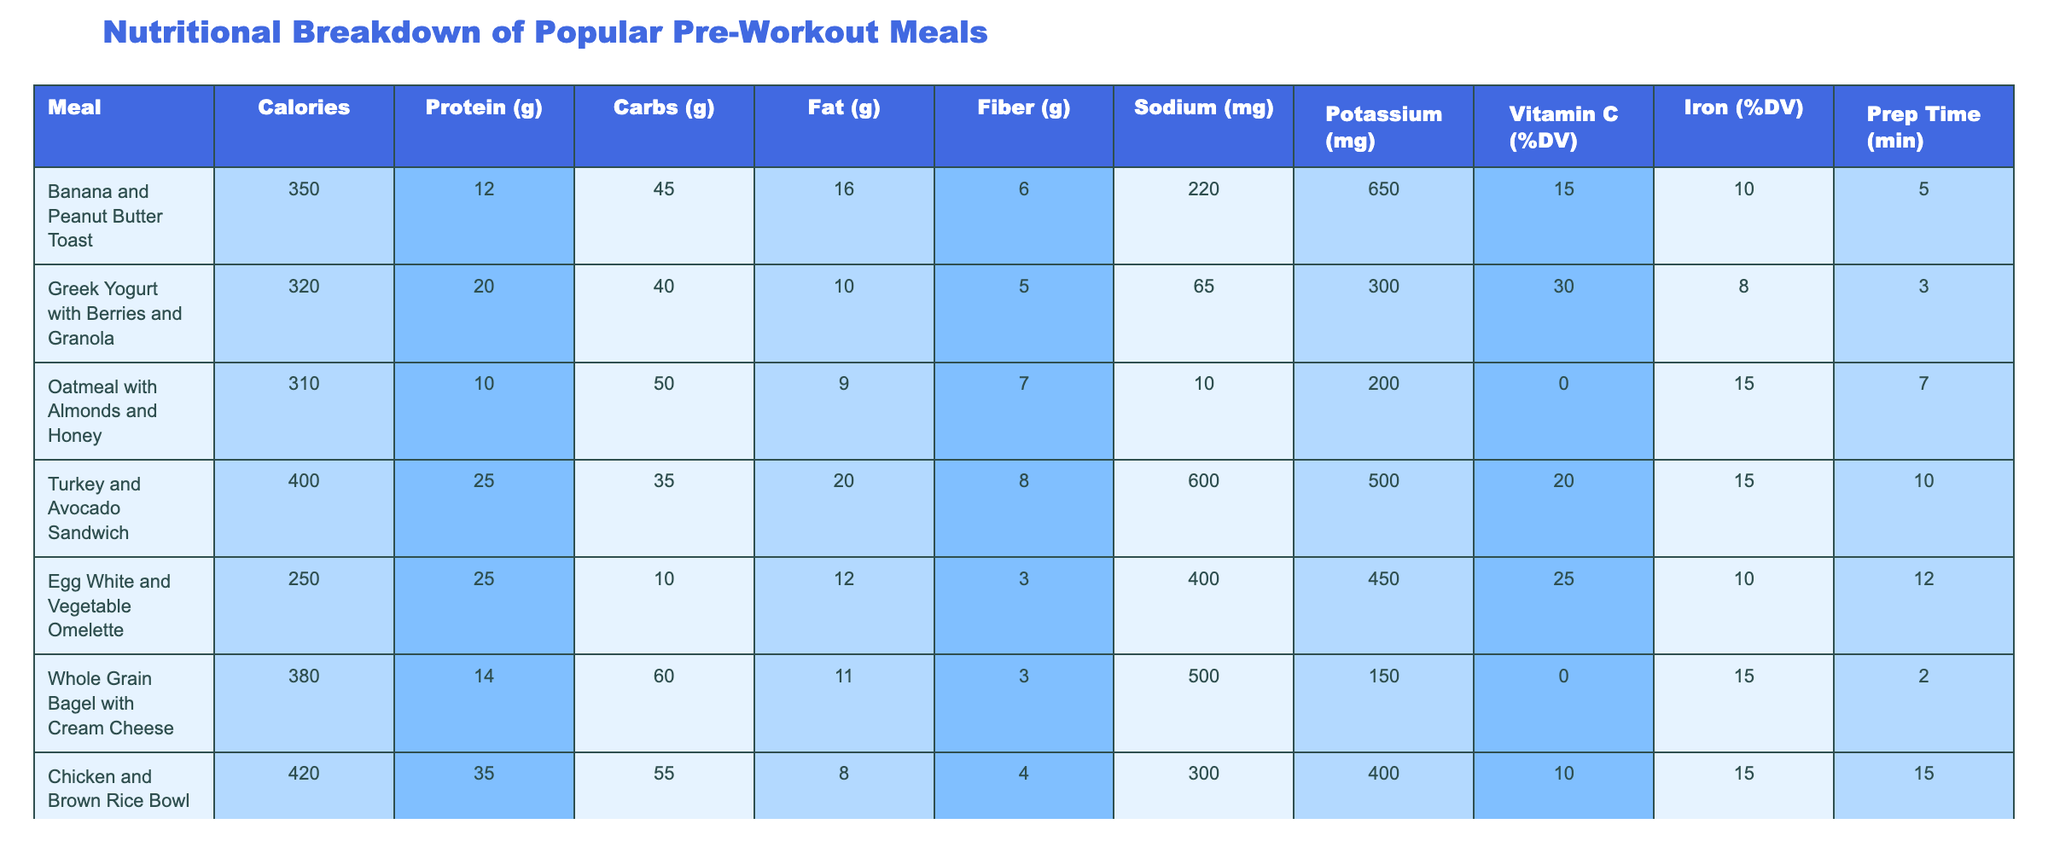What is the meal with the highest protein content? By scanning the protein content values in the table, we find that the "Chicken and Brown Rice Bowl" has the highest protein content at 35 grams.
Answer: Chicken and Brown Rice Bowl Which meal has the least calories? The meal with the least calories, as visible from the table, is the "Egg White and Vegetable Omelette" at 250 calories.
Answer: Egg White and Vegetable Omelette What is the total carbohydrate content of "Greek Yogurt with Berries and Granola" and "Oatmeal with Almonds and Honey"? The carbohydrate content for "Greek Yogurt with Berries and Granola" is 40 grams and for "Oatmeal with Almonds and Honey" is 50 grams. Adding these together gives us 40 + 50 = 90 grams of carbs.
Answer: 90 grams Does any meal provide more than 25% of the daily value for Vitamin C? We can check the Vitamin C percentage for all meals. The "Greek Yogurt with Berries and Granola" and "Egg White and Vegetable Omelette" both provide 30% and 25% respectively, which means the "Greek Yogurt with Berries and Granola" does provide more than 25%.
Answer: Yes What is the average fat content across all meals? To calculate the average fat content, we first sum all the fat values (16 + 10 + 9 + 20 + 12 + 11 + 8 + 15 + 12) = 133 grams. With 9 meals in total, the average is 133 / 9 = 14.78 grams of fat.
Answer: 14.78 grams Which meal offers the most fiber content? We can look at the fiber values in the table, and the "Banana and Peanut Butter Toast" provides the highest fiber content at 6 grams.
Answer: Banana and Peanut Butter Toast What is the difference in sodium content between the "Turkey and Avocado Sandwich" and "Tuna Salad on Whole Wheat Crackers"? The "Turkey and Avocado Sandwich" contains 600 mg of sodium while the "Tuna Salad on Whole Wheat Crackers" contains 550 mg. The difference is 600 - 550 = 50 mg of sodium.
Answer: 50 mg How many meals provide at least 20 grams of protein? By reviewing the table, "Turkey and Avocado Sandwich," "Egg White and Vegetable Omelette," and "Chicken and Brown Rice Bowl" all contain at least 20 grams of protein, making a total of 3 meals.
Answer: 3 meals Is there any meal that contains more than 60 grams of carbohydrates? Examining the table, we see "Whole Grain Bagel with Cream Cheese" has 60 grams of carbs, making it the only meal that meets this inquiry’s requirement (none exceed).
Answer: No 